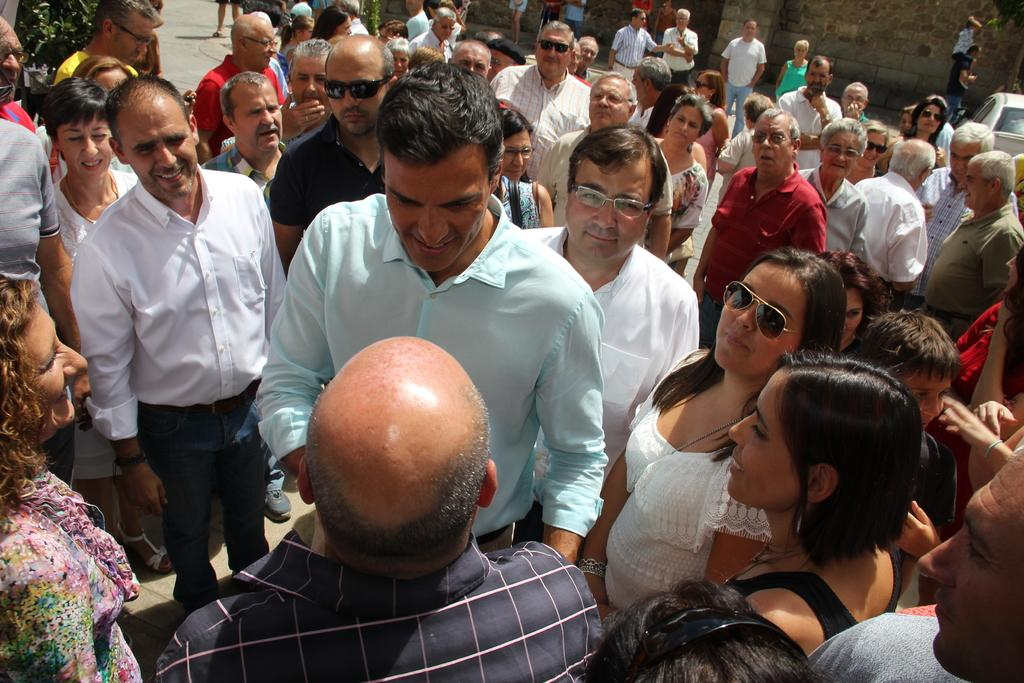What is happening with the group of people in the image? There is a group of people standing in the image. What can be seen on the right side of the people? There is a vehicle and a wall on the right side of the people. Can you describe the interaction between a man and a little boy in the image? A man is carrying a little boy on his shoulders. What type of salt is being used to season the property in the image? There is no salt or property present in the image. How does the man push the little boy on his shoulders in the image? The man is not pushing the little boy in the image; he is carrying him on his shoulders. 